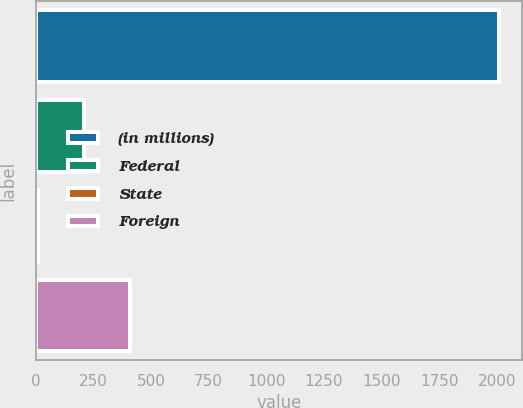<chart> <loc_0><loc_0><loc_500><loc_500><bar_chart><fcel>(in millions)<fcel>Federal<fcel>State<fcel>Foreign<nl><fcel>2010<fcel>209.1<fcel>9<fcel>409.2<nl></chart> 